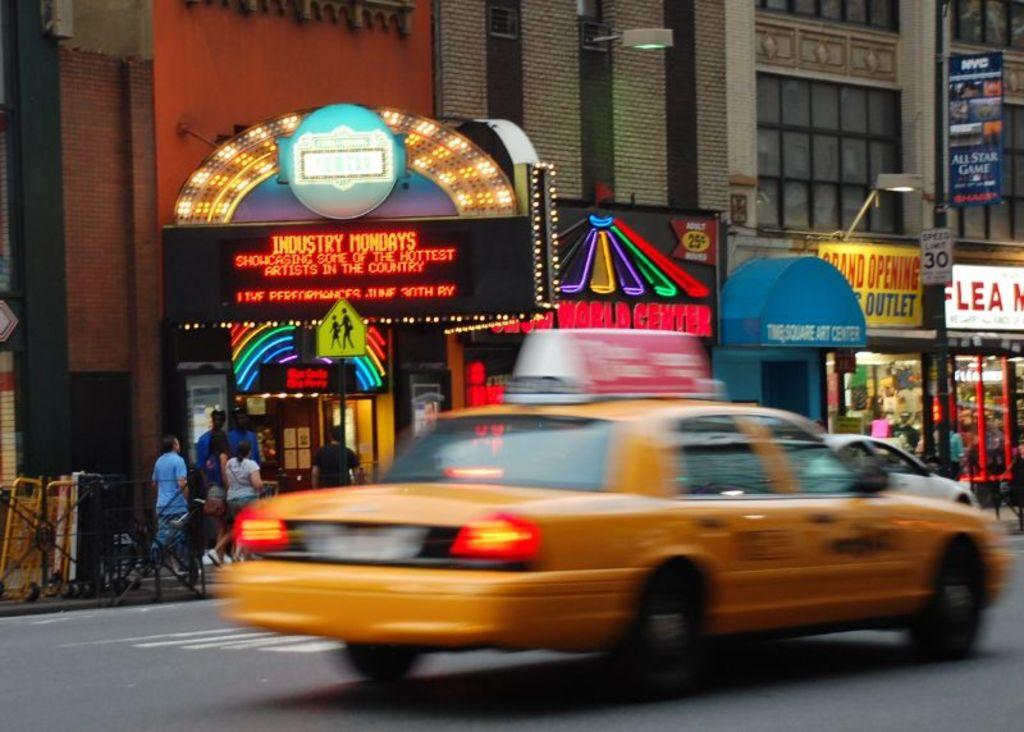Provide a one-sentence caption for the provided image. A yellow taxi passes by an electronic sign advertising Industry Mondays. 